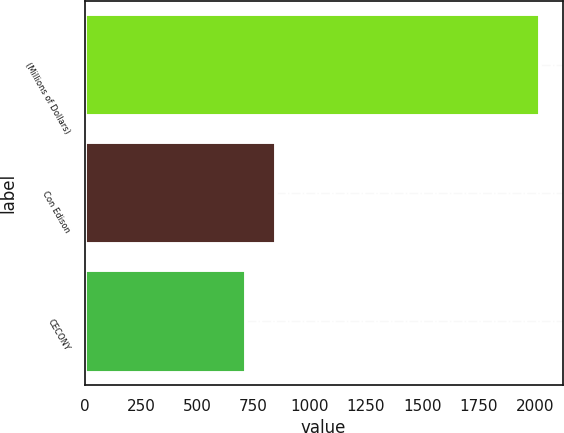Convert chart to OTSL. <chart><loc_0><loc_0><loc_500><loc_500><bar_chart><fcel>(Millions of Dollars)<fcel>Con Edison<fcel>CECONY<nl><fcel>2023<fcel>848.5<fcel>718<nl></chart> 